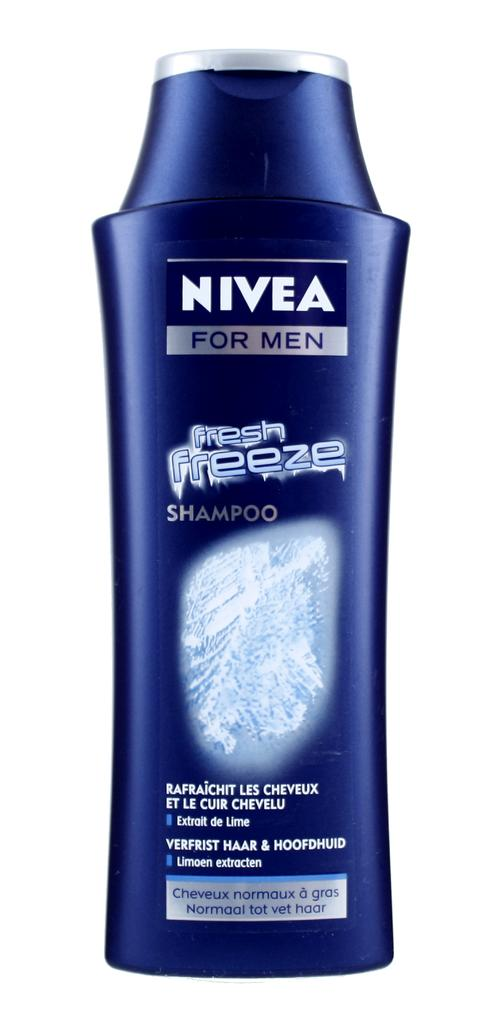<image>
Render a clear and concise summary of the photo. Nivea for men Fresh Freeze shampoo bottle in navy blue. 